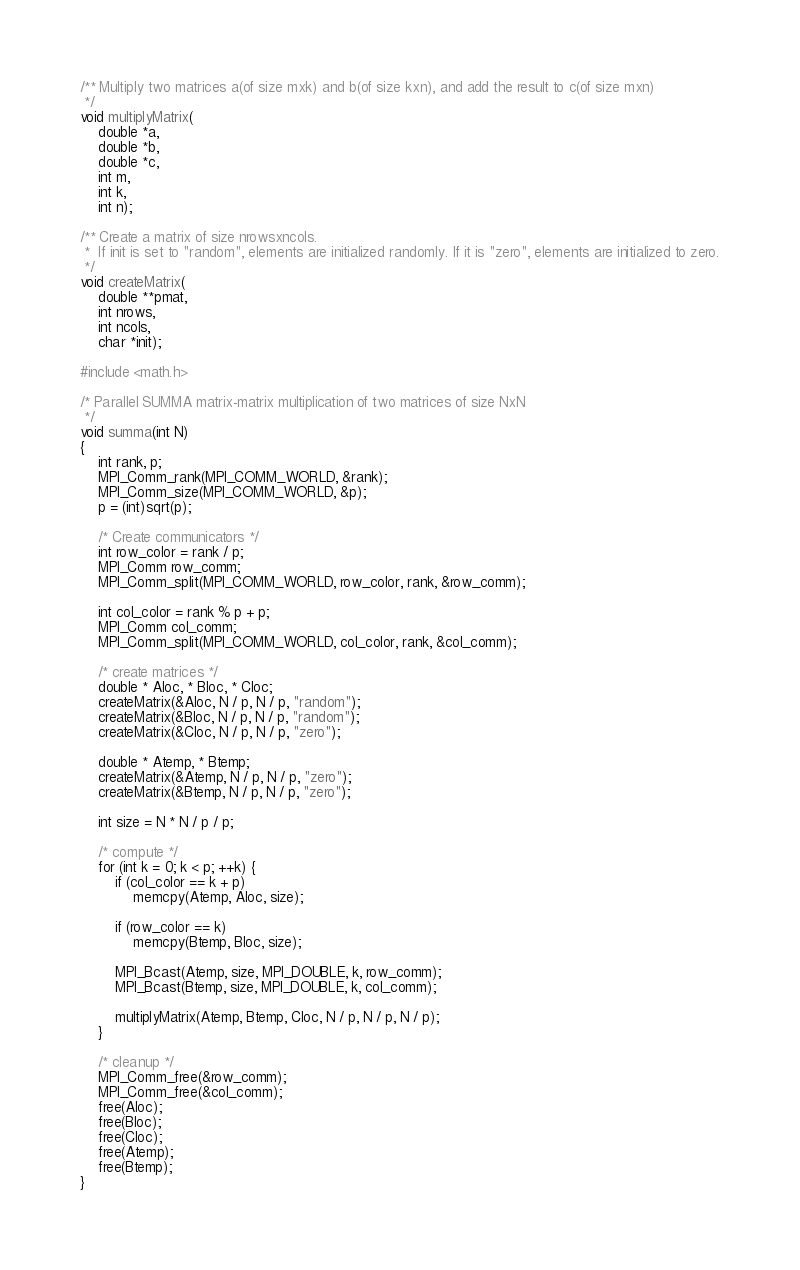Convert code to text. <code><loc_0><loc_0><loc_500><loc_500><_C_>/** Multiply two matrices a(of size mxk) and b(of size kxn), and add the result to c(of size mxn)
 */
void multiplyMatrix(
    double *a,
    double *b,
    double *c,
    int m,
    int k,
    int n);

/** Create a matrix of size nrowsxncols.
 *  If init is set to "random", elements are initialized randomly. If it is "zero", elements are initialized to zero.
 */
void createMatrix(
    double **pmat,
    int nrows,
    int ncols,
    char *init);

#include <math.h>

/* Parallel SUMMA matrix-matrix multiplication of two matrices of size NxN
 */
void summa(int N)
{
    int rank, p;
    MPI_Comm_rank(MPI_COMM_WORLD, &rank);
    MPI_Comm_size(MPI_COMM_WORLD, &p);
    p = (int)sqrt(p);

    /* Create communicators */
    int row_color = rank / p;
    MPI_Comm row_comm;
    MPI_Comm_split(MPI_COMM_WORLD, row_color, rank, &row_comm);

    int col_color = rank % p + p;
    MPI_Comm col_comm;
    MPI_Comm_split(MPI_COMM_WORLD, col_color, rank, &col_comm);

    /* create matrices */
    double * Aloc, * Bloc, * Cloc;
    createMatrix(&Aloc, N / p, N / p, "random");
    createMatrix(&Bloc, N / p, N / p, "random");
    createMatrix(&Cloc, N / p, N / p, "zero");

    double * Atemp, * Btemp;
    createMatrix(&Atemp, N / p, N / p, "zero");
    createMatrix(&Btemp, N / p, N / p, "zero");

    int size = N * N / p / p;

    /* compute */
    for (int k = 0; k < p; ++k) {
        if (col_color == k + p)
            memcpy(Atemp, Aloc, size);

        if (row_color == k)
            memcpy(Btemp, Bloc, size);

        MPI_Bcast(Atemp, size, MPI_DOUBLE, k, row_comm);
        MPI_Bcast(Btemp, size, MPI_DOUBLE, k, col_comm);

        multiplyMatrix(Atemp, Btemp, Cloc, N / p, N / p, N / p);
    }

    /* cleanup */
    MPI_Comm_free(&row_comm);
    MPI_Comm_free(&col_comm);
    free(Aloc);
    free(Bloc);
    free(Cloc);
    free(Atemp);
    free(Btemp);
}
</code> 